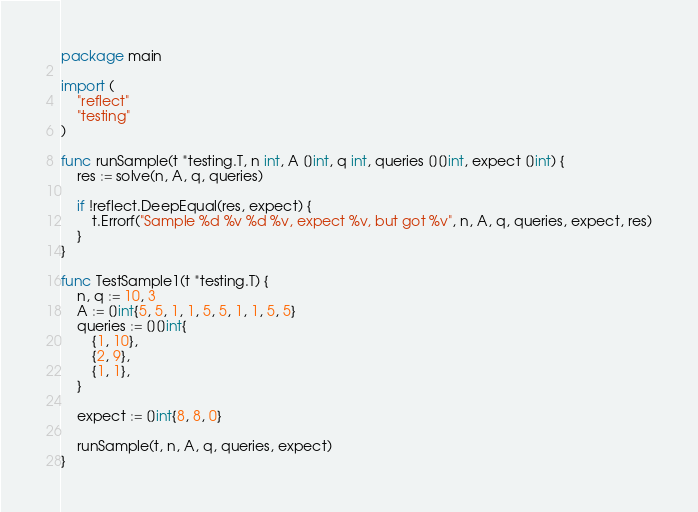<code> <loc_0><loc_0><loc_500><loc_500><_Go_>package main

import (
	"reflect"
	"testing"
)

func runSample(t *testing.T, n int, A []int, q int, queries [][]int, expect []int) {
	res := solve(n, A, q, queries)

	if !reflect.DeepEqual(res, expect) {
		t.Errorf("Sample %d %v %d %v, expect %v, but got %v", n, A, q, queries, expect, res)
	}
}

func TestSample1(t *testing.T) {
	n, q := 10, 3
	A := []int{5, 5, 1, 1, 5, 5, 1, 1, 5, 5}
	queries := [][]int{
		{1, 10},
		{2, 9},
		{1, 1},
	}

	expect := []int{8, 8, 0}

	runSample(t, n, A, q, queries, expect)
}
</code> 